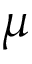Convert formula to latex. <formula><loc_0><loc_0><loc_500><loc_500>\mu</formula> 